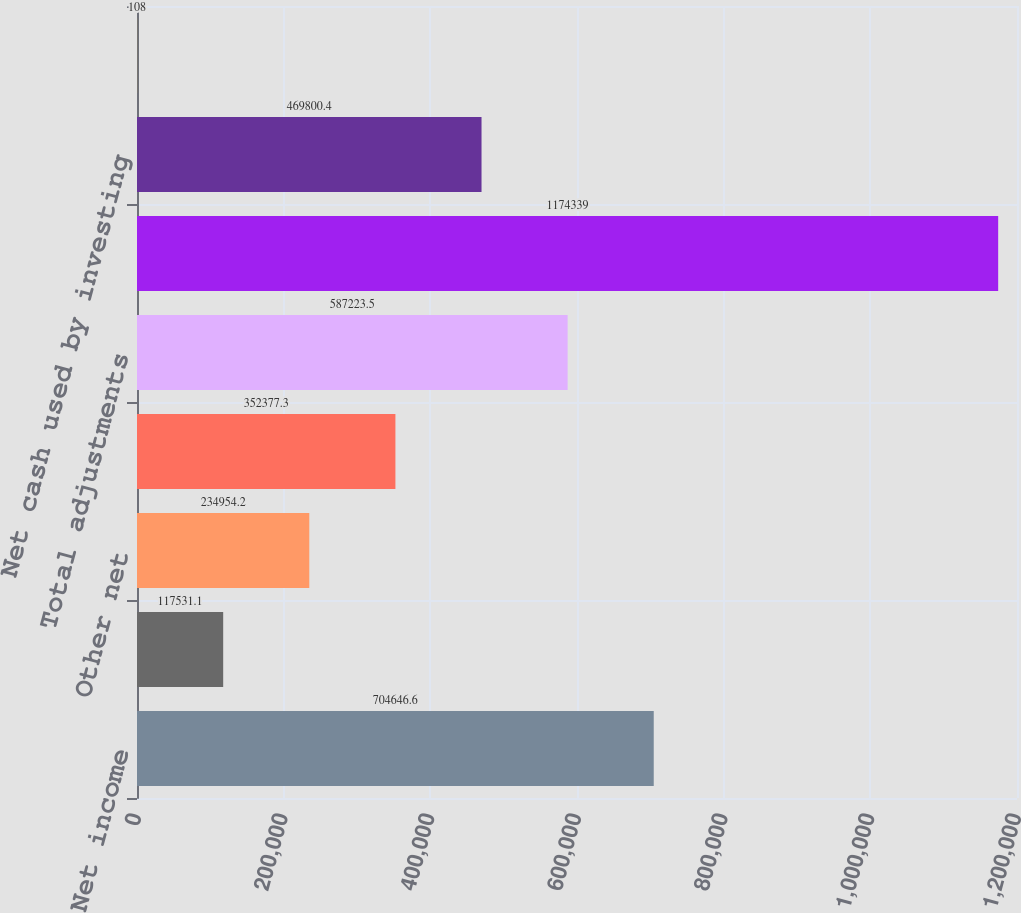<chart> <loc_0><loc_0><loc_500><loc_500><bar_chart><fcel>Net income<fcel>Deferred income taxes<fcel>Other net<fcel>Accounts payable and accrued<fcel>Total adjustments<fcel>Net cash provided by operating<fcel>Net cash used by investing<fcel>108<nl><fcel>704647<fcel>117531<fcel>234954<fcel>352377<fcel>587224<fcel>1.17434e+06<fcel>469800<fcel>108<nl></chart> 